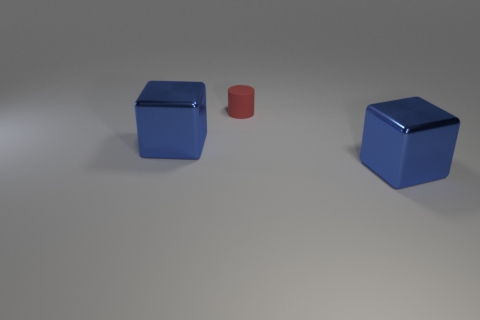Are there any other things that have the same size as the rubber thing?
Offer a very short reply. No. The red thing is what size?
Ensure brevity in your answer.  Small. There is a matte cylinder to the left of the block right of the tiny matte thing; what is its size?
Provide a succinct answer. Small. What is the material of the tiny red cylinder?
Provide a succinct answer. Rubber. The blue object behind the blue object in front of the cube that is left of the matte object is made of what material?
Your answer should be compact. Metal. Are there any other things that are the same shape as the tiny object?
Provide a short and direct response. No. Does the big thing right of the red object have the same color as the thing to the left of the small rubber cylinder?
Keep it short and to the point. Yes. Is the number of large blue shiny cubes left of the tiny thing greater than the number of small yellow rubber balls?
Give a very brief answer. Yes. How many other things are the same size as the red rubber thing?
Provide a succinct answer. 0. How many metallic things are both to the left of the small red rubber cylinder and to the right of the matte thing?
Your answer should be very brief. 0. 